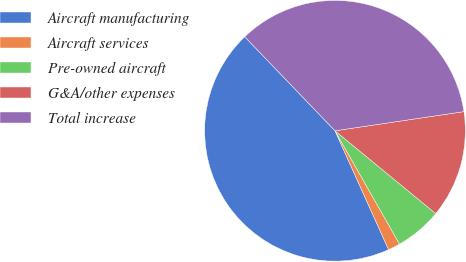Convert chart to OTSL. <chart><loc_0><loc_0><loc_500><loc_500><pie_chart><fcel>Aircraft manufacturing<fcel>Aircraft services<fcel>Pre-owned aircraft<fcel>G&A/other expenses<fcel>Total increase<nl><fcel>44.57%<fcel>1.5%<fcel>5.81%<fcel>13.3%<fcel>34.83%<nl></chart> 